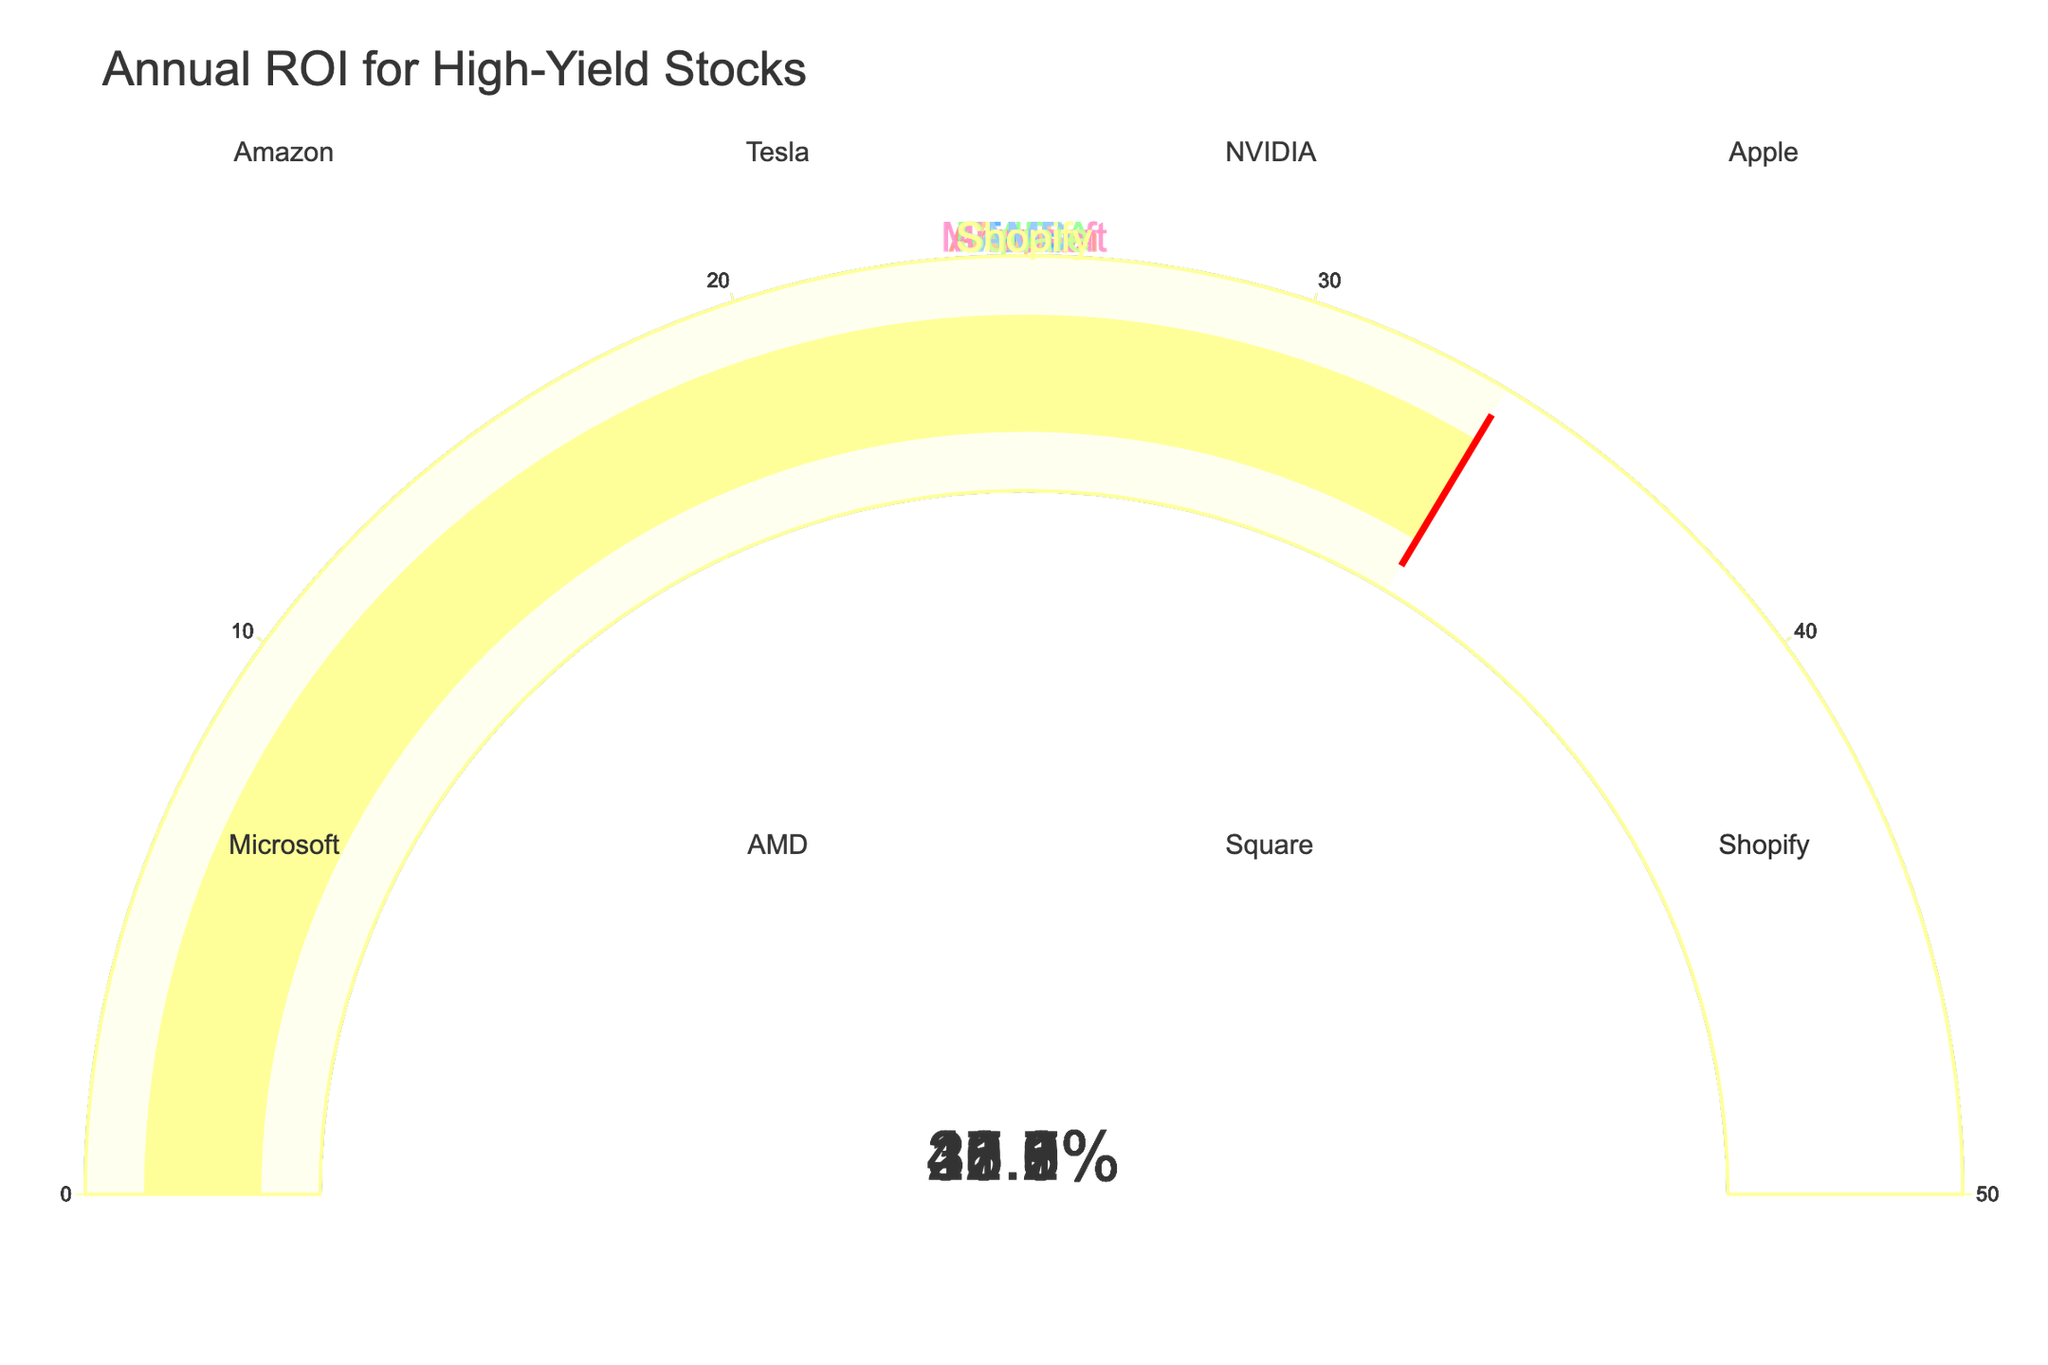What's the title of the figure? The title is placed at the top of the plot, it reads "Annual ROI for High-Yield Stocks".
Answer: Annual ROI for High-Yield Stocks How many companies are included in the figure? By counting the number of subplots or gauges in the figure, each representing a different company, we see that there are 8 companies.
Answer: 8 Which company has the highest annual ROI? By looking at the values displayed on each gauge, the one with the highest number is NVIDIA with 45.2%.
Answer: NVIDIA What is the annual ROI for Microsoft? Locate the gauge for Microsoft, which shows its annual ROI. The value displayed is 27.3%.
Answer: 27.3% What's the average annual ROI of all the companies? Add all the annual ROI values: 22.5 + 31.8 + 45.2 + 18.7 + 27.3 + 35.9 + 40.1 + 33.6 = 255.1. Then divide by the number of companies, 255.1 / 8 = 31.89.
Answer: 31.89 Which companies have an annual ROI greater than 30%? Check each gauge for companies with ROI over 30%. These companies are Tesla (31.8%), NVIDIA (45.2%), AMD (35.9%), Square (40.1%), and Shopify (33.6%).
Answer: Tesla, NVIDIA, AMD, Square, Shopify What is the difference in annual ROI between Apple and Amazon? Subtract Apple's ROI (18.7%) from Amazon's ROI (22.5%). The difference is 22.5 - 18.7 = 3.8%.
Answer: 3.8% What's the combined annual ROI of the top three companies listed in the figure? Identify the top three ROIs: NVIDIA (45.2%), Square (40.1%), and AMD (35.9%). Add them together: 45.2 + 40.1 + 35.9 = 121.2.
Answer: 121.2 Is Apple's annual ROI above or below the average annual ROI of the companies displayed? Since the average ROI is 31.89% and Apple's ROI is 18.7%, which is less than 31.89%, Apple's ROI is below average.
Answer: Below 